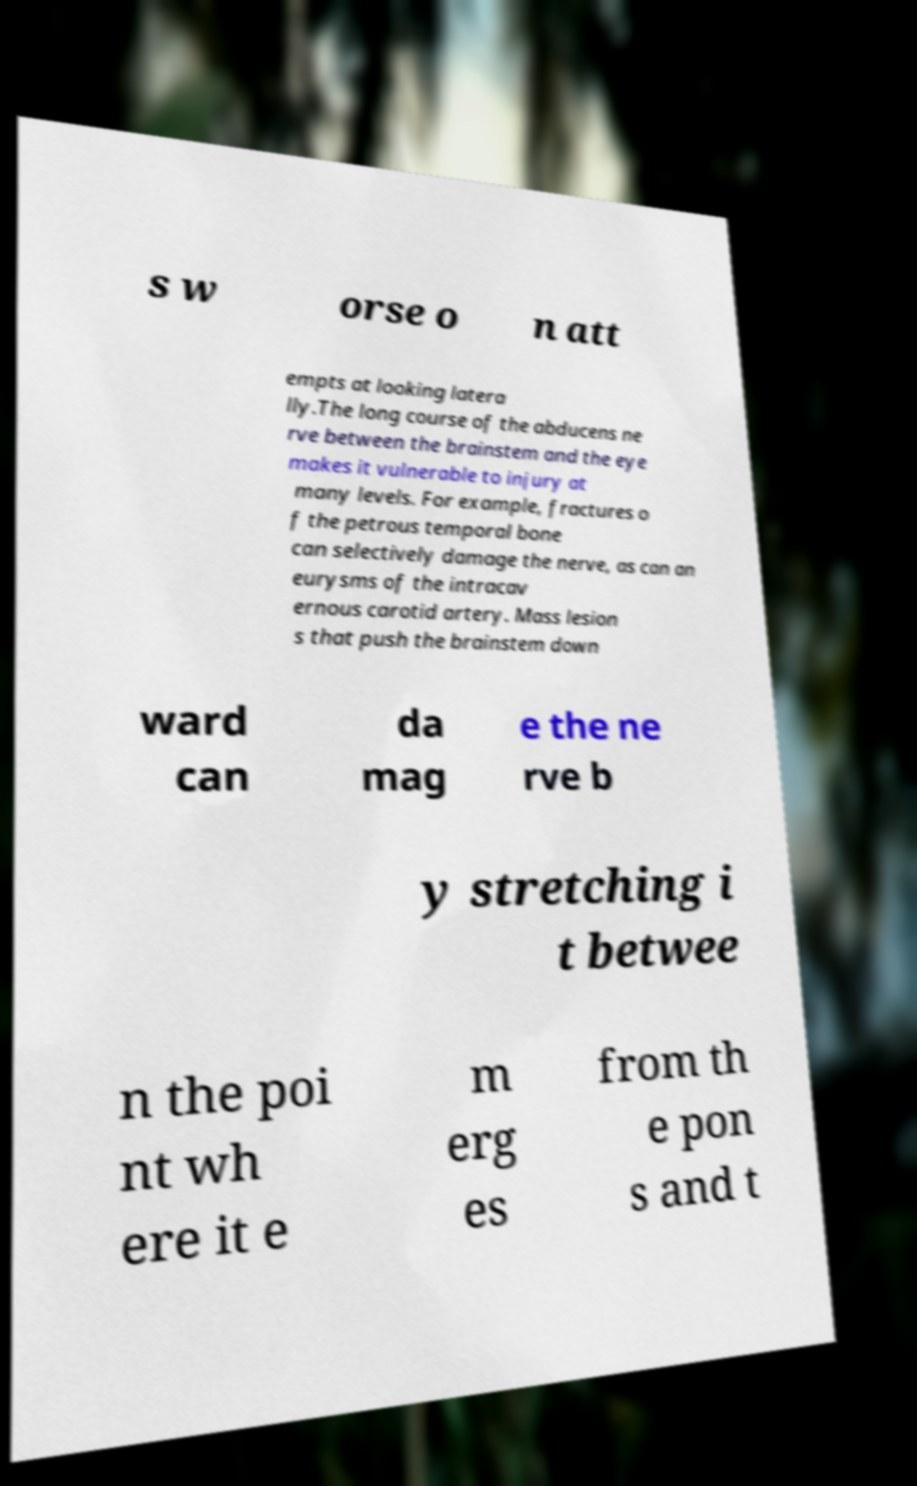For documentation purposes, I need the text within this image transcribed. Could you provide that? s w orse o n att empts at looking latera lly.The long course of the abducens ne rve between the brainstem and the eye makes it vulnerable to injury at many levels. For example, fractures o f the petrous temporal bone can selectively damage the nerve, as can an eurysms of the intracav ernous carotid artery. Mass lesion s that push the brainstem down ward can da mag e the ne rve b y stretching i t betwee n the poi nt wh ere it e m erg es from th e pon s and t 